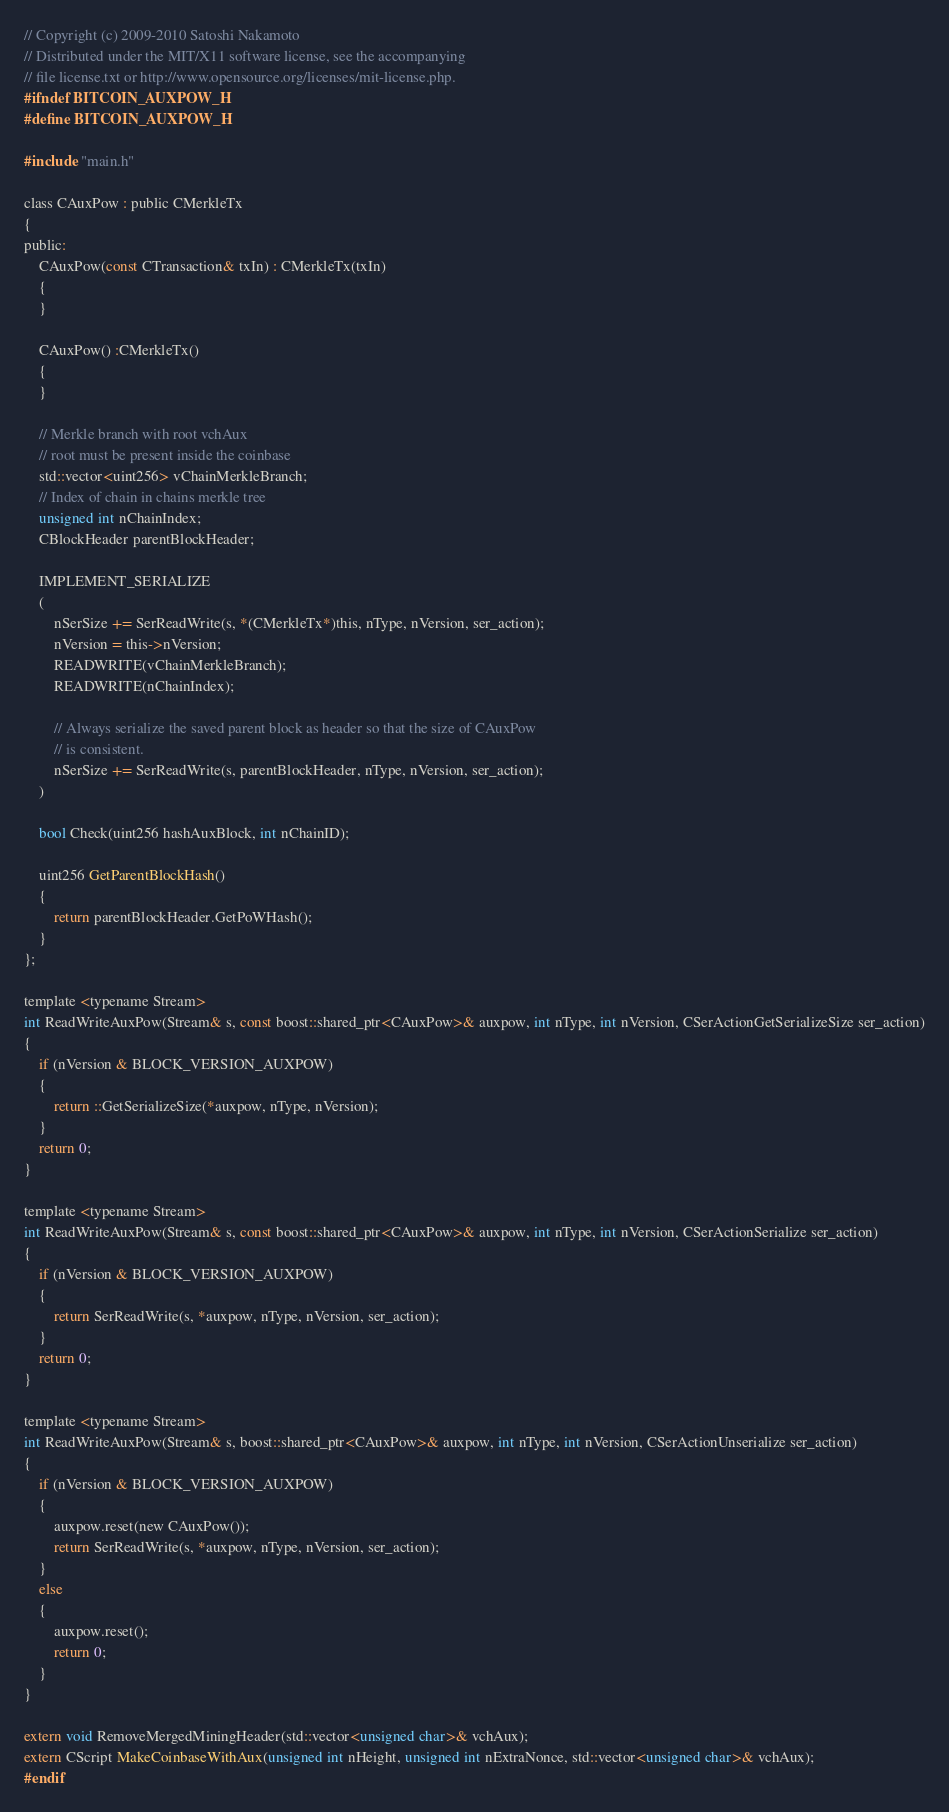<code> <loc_0><loc_0><loc_500><loc_500><_C_>// Copyright (c) 2009-2010 Satoshi Nakamoto
// Distributed under the MIT/X11 software license, see the accompanying
// file license.txt or http://www.opensource.org/licenses/mit-license.php.
#ifndef BITCOIN_AUXPOW_H
#define BITCOIN_AUXPOW_H

#include "main.h"

class CAuxPow : public CMerkleTx
{
public:
    CAuxPow(const CTransaction& txIn) : CMerkleTx(txIn)
    {
    }

    CAuxPow() :CMerkleTx()
    {
    }

    // Merkle branch with root vchAux
    // root must be present inside the coinbase
    std::vector<uint256> vChainMerkleBranch;
    // Index of chain in chains merkle tree
    unsigned int nChainIndex;
    CBlockHeader parentBlockHeader;

    IMPLEMENT_SERIALIZE
    (
        nSerSize += SerReadWrite(s, *(CMerkleTx*)this, nType, nVersion, ser_action);
        nVersion = this->nVersion;
        READWRITE(vChainMerkleBranch);
        READWRITE(nChainIndex);

        // Always serialize the saved parent block as header so that the size of CAuxPow
        // is consistent.
        nSerSize += SerReadWrite(s, parentBlockHeader, nType, nVersion, ser_action);
    )

    bool Check(uint256 hashAuxBlock, int nChainID);

    uint256 GetParentBlockHash()
    {
        return parentBlockHeader.GetPoWHash();
    }
};

template <typename Stream>
int ReadWriteAuxPow(Stream& s, const boost::shared_ptr<CAuxPow>& auxpow, int nType, int nVersion, CSerActionGetSerializeSize ser_action)
{
    if (nVersion & BLOCK_VERSION_AUXPOW)
    {
        return ::GetSerializeSize(*auxpow, nType, nVersion);
    }
    return 0;
}

template <typename Stream>
int ReadWriteAuxPow(Stream& s, const boost::shared_ptr<CAuxPow>& auxpow, int nType, int nVersion, CSerActionSerialize ser_action)
{
    if (nVersion & BLOCK_VERSION_AUXPOW)
    {
        return SerReadWrite(s, *auxpow, nType, nVersion, ser_action);
    }
    return 0;
}

template <typename Stream>
int ReadWriteAuxPow(Stream& s, boost::shared_ptr<CAuxPow>& auxpow, int nType, int nVersion, CSerActionUnserialize ser_action)
{
    if (nVersion & BLOCK_VERSION_AUXPOW)
    {
        auxpow.reset(new CAuxPow());
        return SerReadWrite(s, *auxpow, nType, nVersion, ser_action);
    }
    else
    {
        auxpow.reset();
        return 0;
    }
}

extern void RemoveMergedMiningHeader(std::vector<unsigned char>& vchAux);
extern CScript MakeCoinbaseWithAux(unsigned int nHeight, unsigned int nExtraNonce, std::vector<unsigned char>& vchAux);
#endif
</code> 